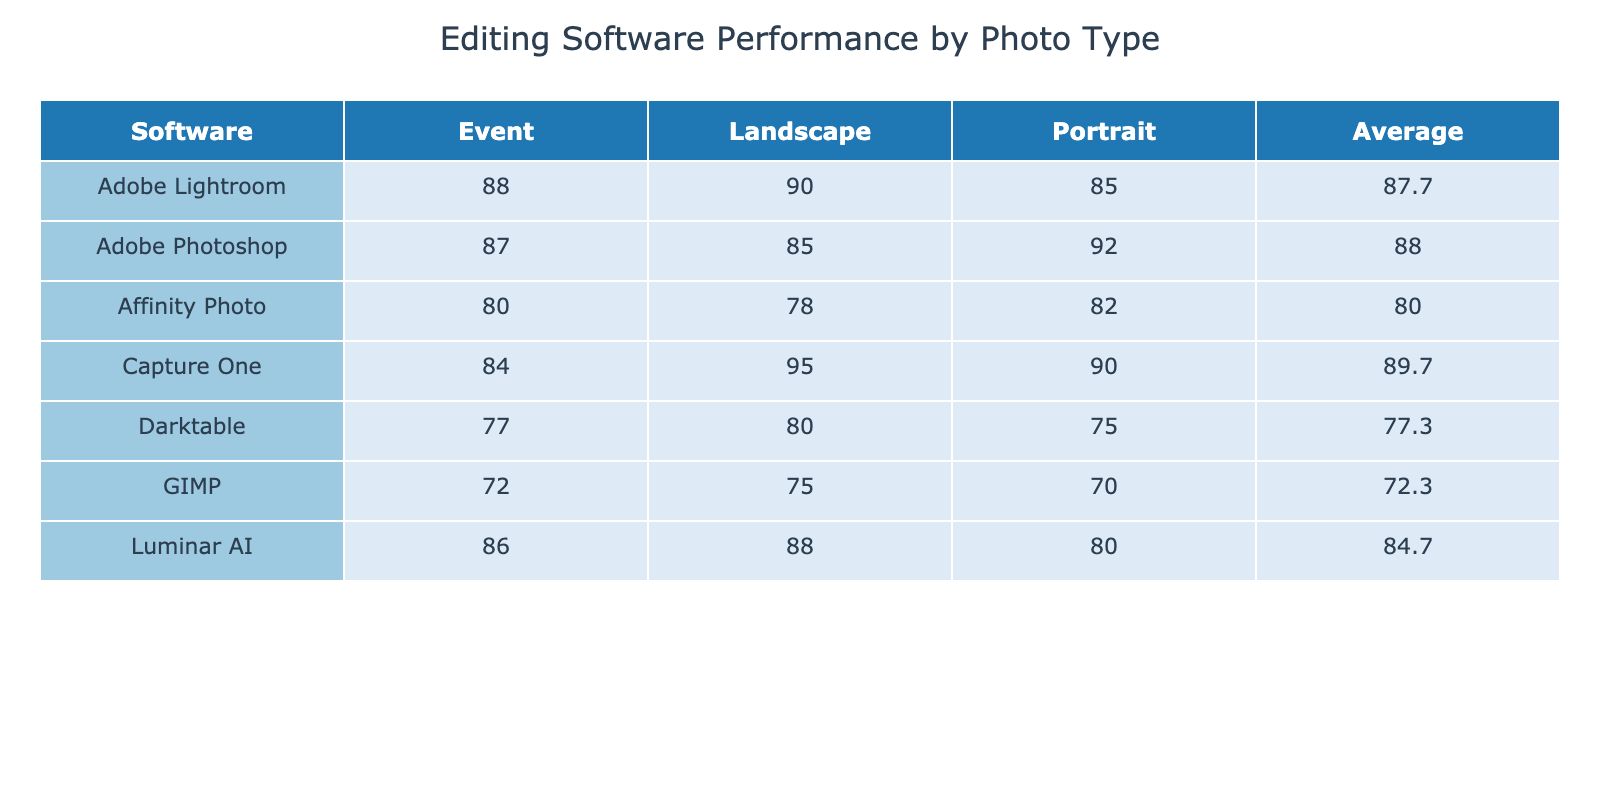What is the highest performance score for portrait photography software? Looking through the portrait column, Adobe Photoshop has the highest score at 92.
Answer: 92 Which software has the lowest performance score for landscape photography? By checking the landscape column, Affinity Photo shows the lowest score of 78.
Answer: 78 What is the average performance score of Capture One across all photo types? The scores for Capture One are 90 (portrait), 95 (landscape), and 84 (event). Summing these gives 90 + 95 + 84 = 269, divided by 3 yields an average of 269/3 = 89.67, rounded to 89.7.
Answer: 89.7 Does any software have the same performance score for portrait and event types? Looking at the portrait and event columns, Affinity Photo has 82 in portrait and 80 in event, while GIMP has 70 in portrait and 72 in event. Therefore, none of the software have the same score for these two types.
Answer: No Which software performs best on event photography compared to landscape photography? Analyzing the event column: Adobe Lightroom has 88, Adobe Photoshop has 87, Capture One has 84, and Luminar AI has 86. In the landscape column, Adobe Lightroom scored 90, whereas others score lower than their event counterparts. Thus, Adobe Lightroom outperforms the others in event photography but is slightly lower in landscape photography.
Answer: Adobe Lightroom What is the total sum of performance scores for all software in portrait photography? Summing the scores for all software in the portrait column: 85 + 92 + 90 + 82 + 80 + 75 + 70 = 494.
Answer: 494 Is Capture One better for landscape or event photography based on performance scores? For Capture One, the performance score is 95 for landscape and 84 for event photography. Since 95 is higher than 84, Capture One performs better in landscape photography.
Answer: Landscape photography Which software has a higher average performance score: Adobe Photoshop or Affinity Photo? First, calculate the averages: Adobe Photoshop scores are 92 (portrait), 85 (landscape), and 87 (event), totaling 264. The average is 264/3 = 88. Affinity Photo scores are 82 (portrait), 78 (landscape), and 80 (event), totaling 240 with an average of 240/3 = 80. Thus, Adobe Photoshop has a higher average at 88 compared to Affinity Photo's 80.
Answer: Adobe Photoshop 